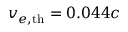<formula> <loc_0><loc_0><loc_500><loc_500>v _ { e , { t h } } = 0 . 0 4 4 c</formula> 